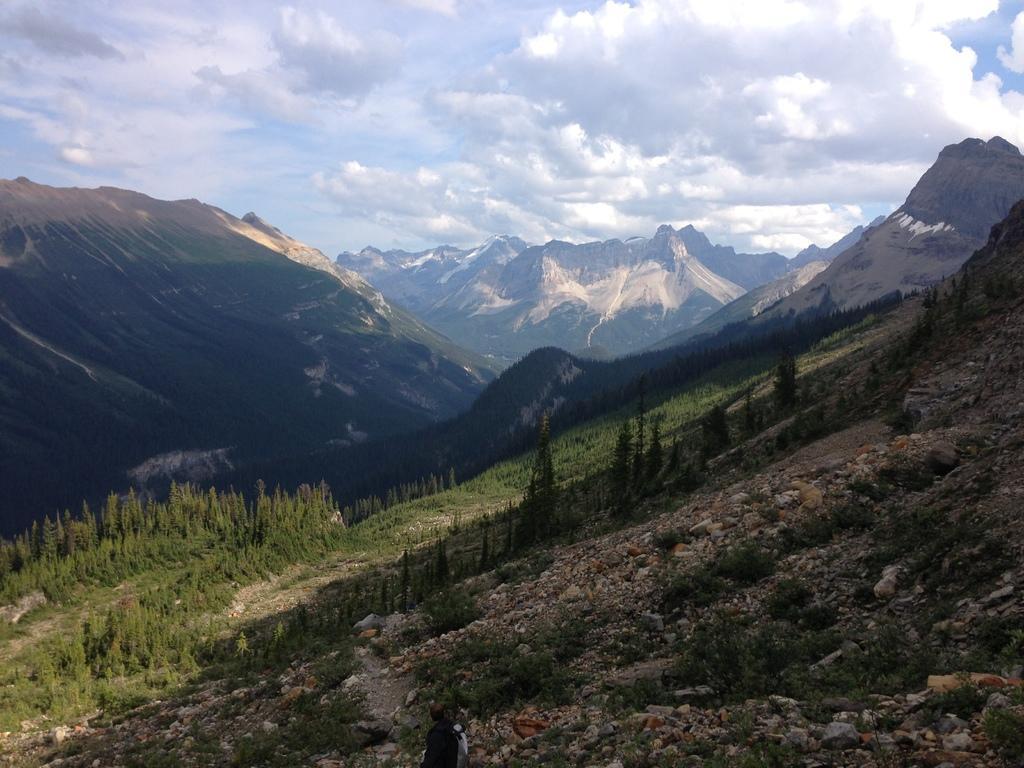Could you give a brief overview of what you see in this image? It is a hill station there are a lot of mountains and on the first mountain there is a man walking in between the rocks. 